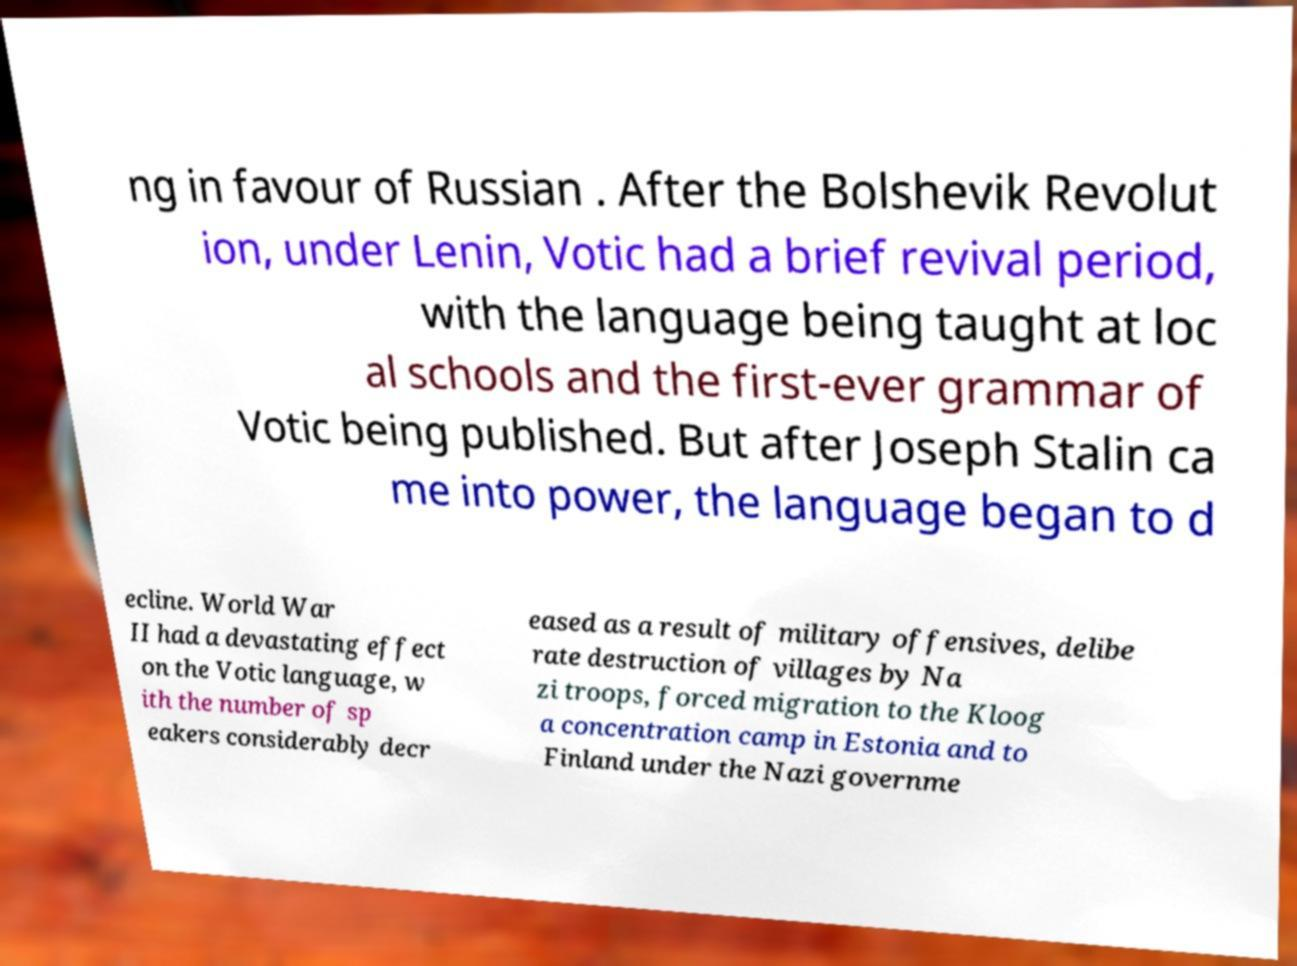Could you assist in decoding the text presented in this image and type it out clearly? ng in favour of Russian . After the Bolshevik Revolut ion, under Lenin, Votic had a brief revival period, with the language being taught at loc al schools and the first-ever grammar of Votic being published. But after Joseph Stalin ca me into power, the language began to d ecline. World War II had a devastating effect on the Votic language, w ith the number of sp eakers considerably decr eased as a result of military offensives, delibe rate destruction of villages by Na zi troops, forced migration to the Kloog a concentration camp in Estonia and to Finland under the Nazi governme 